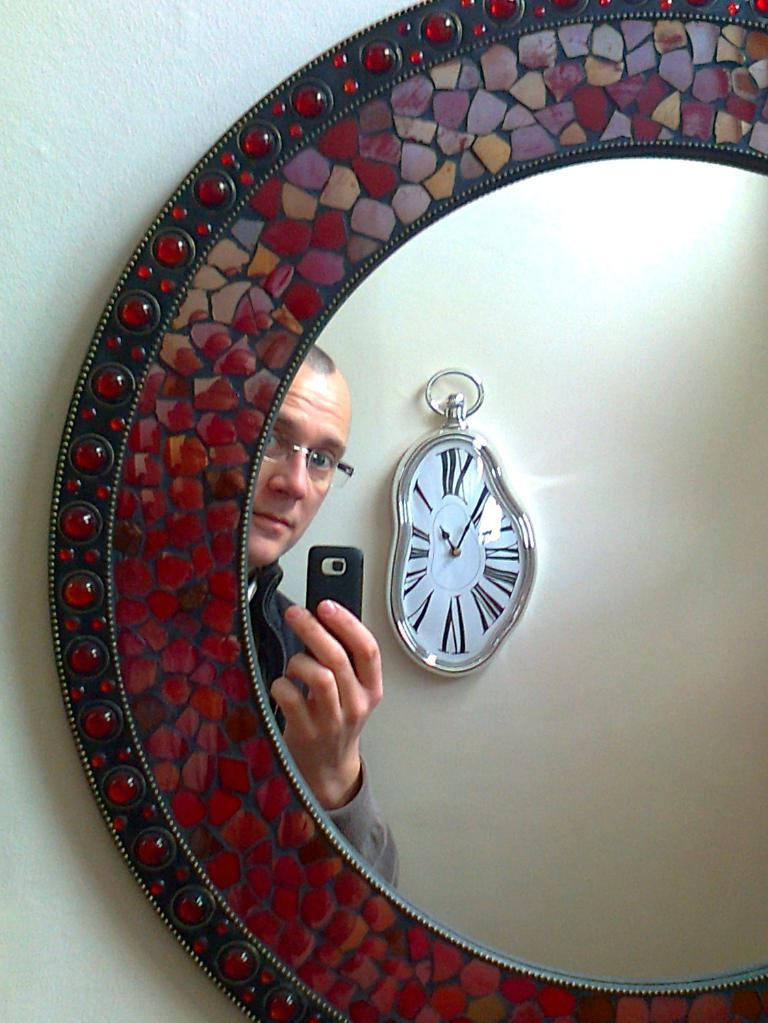What object is attached to the wall in the image? There is a mirror on the wall in the image. What can be seen in the mirror's reflection? The reflection of a wall clock and a man holding a mobile in his hand are visible in the mirror. What is the man doing in the image? The man is holding a mobile in his hand, as seen in the mirror's reflection. How far away is the sail from the mirror in the image? There is no sail present in the image, so it cannot be determined how far away it might be from the mirror. 